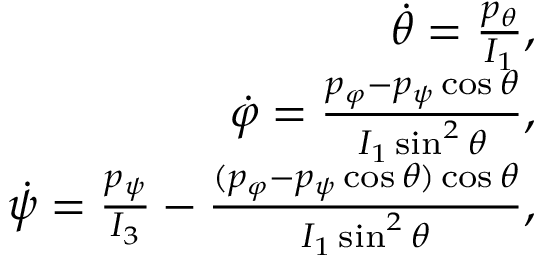Convert formula to latex. <formula><loc_0><loc_0><loc_500><loc_500>\begin{array} { r } { \dot { \theta } = \frac { p _ { \theta } } { I _ { 1 } } , } \\ { \dot { \varphi } = \frac { p _ { \varphi } - p _ { \psi } \cos \theta } { I _ { 1 } \sin ^ { 2 } \theta } , } \\ { \dot { \psi } = \frac { p _ { \psi } } { I _ { 3 } } - \frac { ( p _ { \varphi } - p _ { \psi } \cos \theta ) \cos \theta } { I _ { 1 } \sin ^ { 2 } \theta } , } \end{array}</formula> 